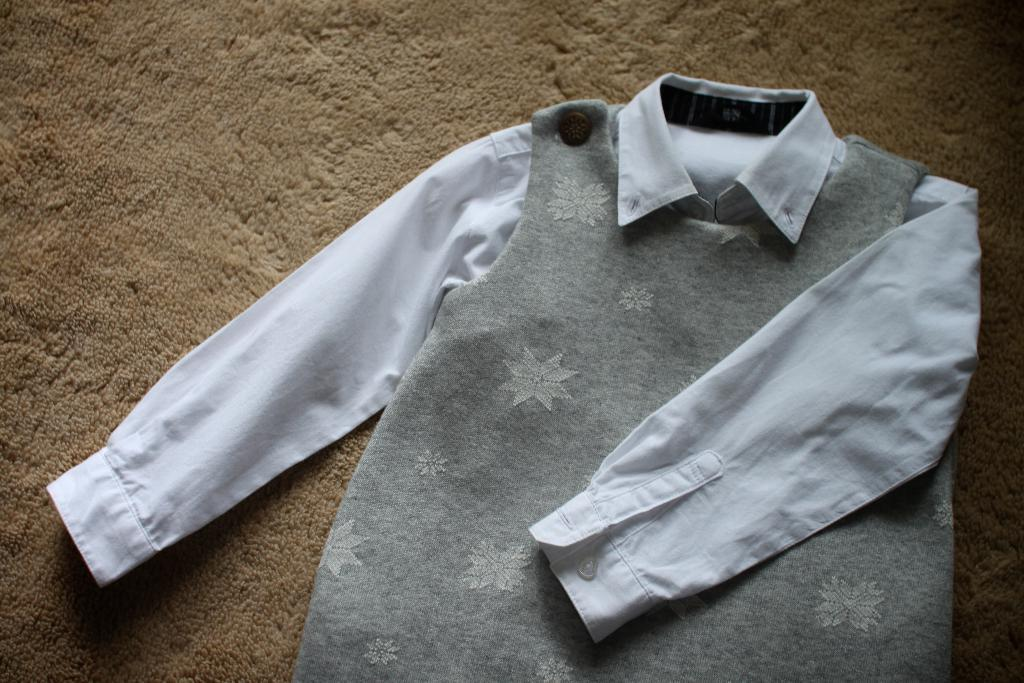What color is the dress in the image? The dress in the image is white and ash colored. What is the dress placed on in the image? The dress is on a brown color surface. How many writers are present in the image? There are no writers present in the image; it only features a dress on a surface. 